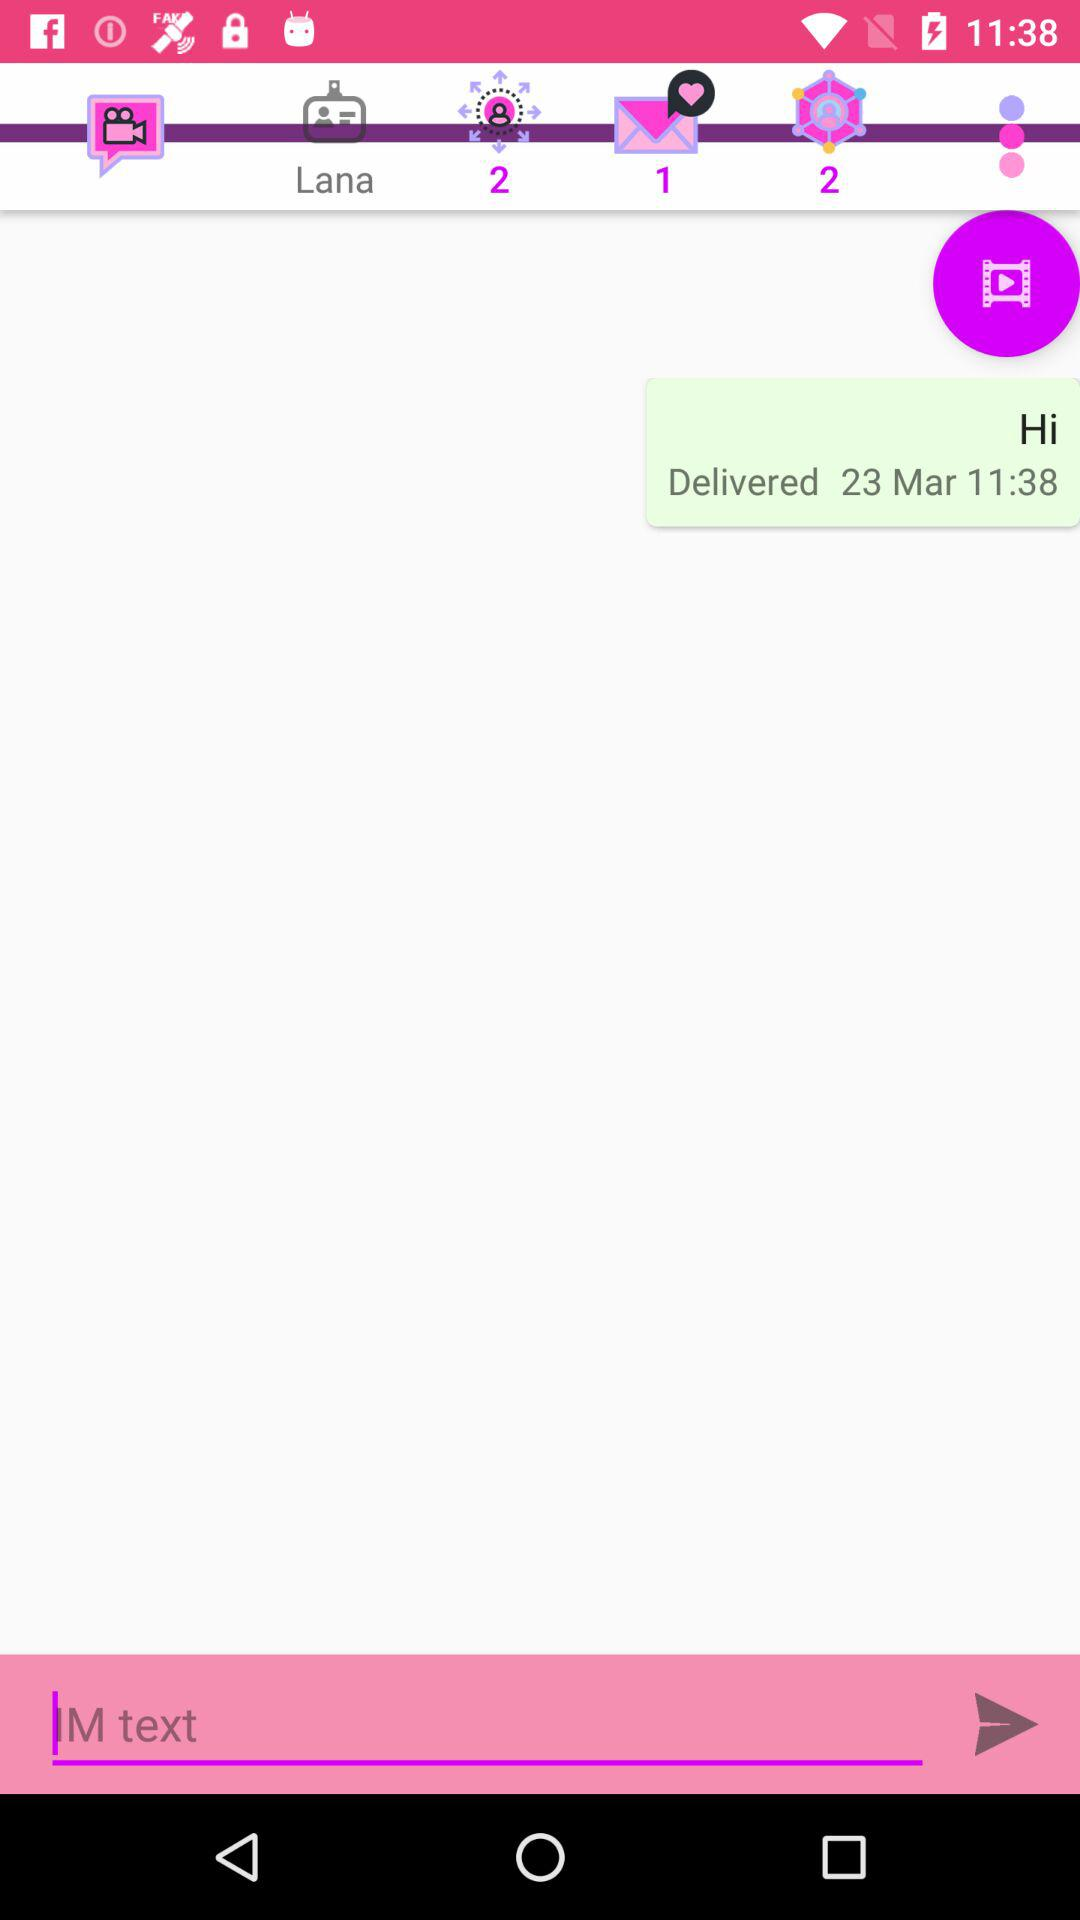On what day was the message delivered? The message was delivered on March 23 at 11:38. 